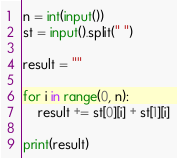<code> <loc_0><loc_0><loc_500><loc_500><_Python_>n = int(input())
st = input().split(" ")

result = ""

for i in range(0, n):
    result += st[0][i] + st[1][i]

print(result)
</code> 